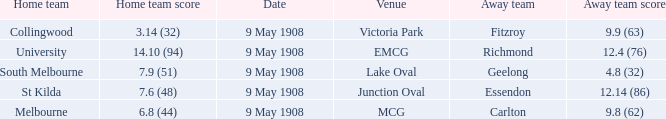Name the home team score for south melbourne home team 7.9 (51). 